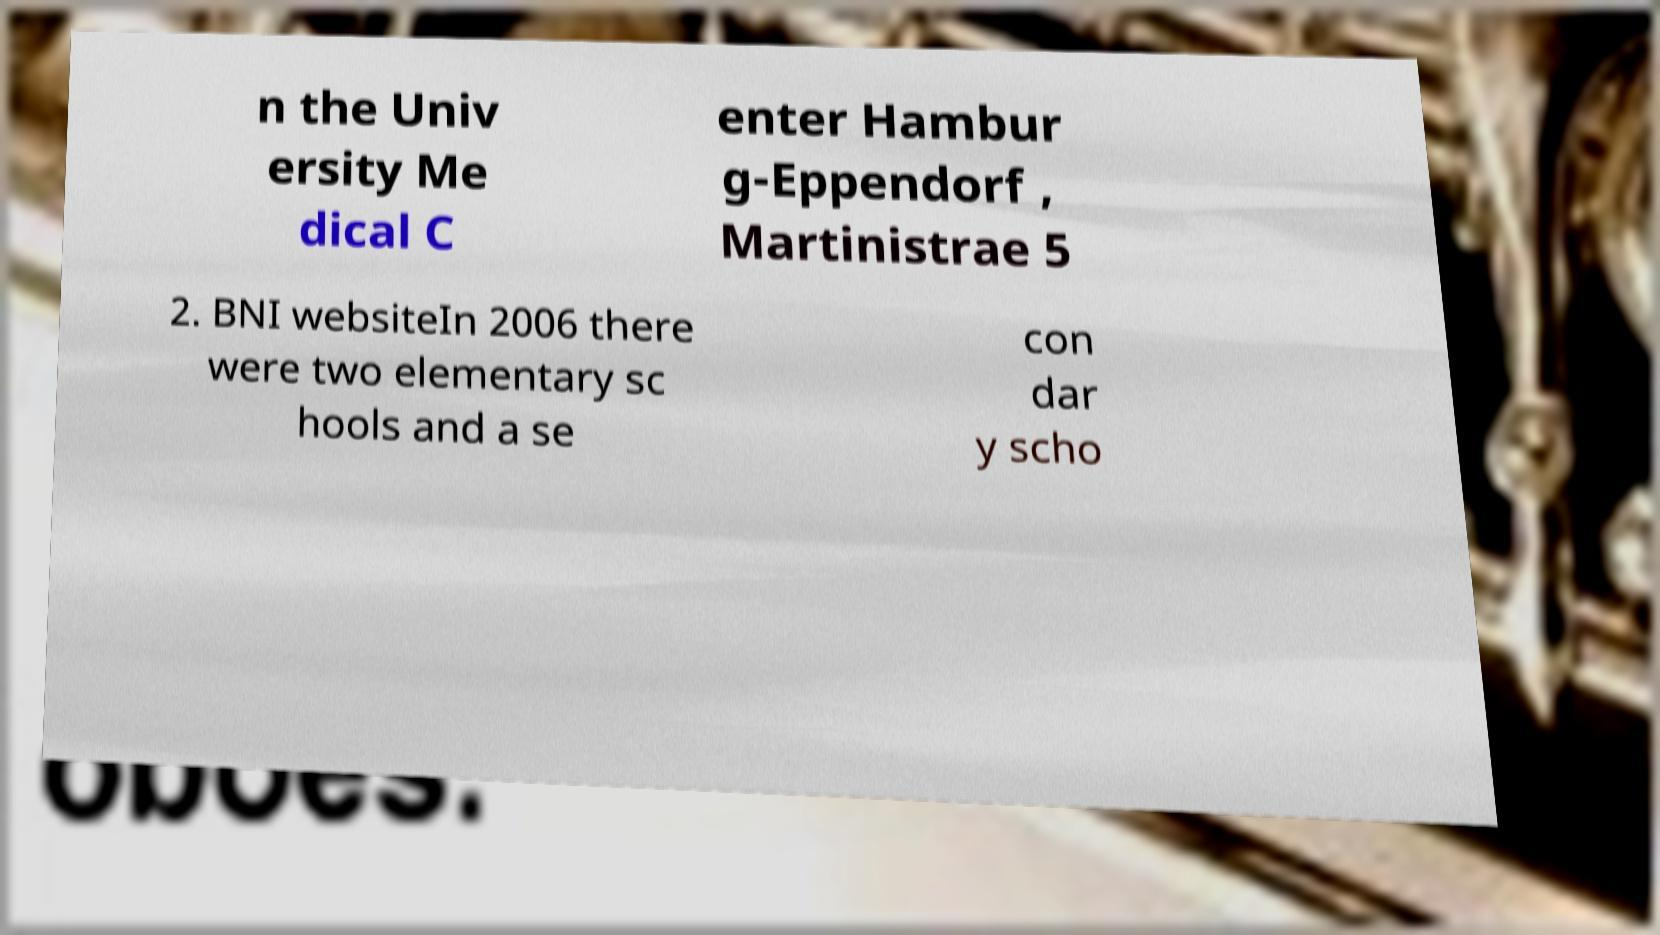Can you read and provide the text displayed in the image?This photo seems to have some interesting text. Can you extract and type it out for me? n the Univ ersity Me dical C enter Hambur g-Eppendorf , Martinistrae 5 2. BNI websiteIn 2006 there were two elementary sc hools and a se con dar y scho 